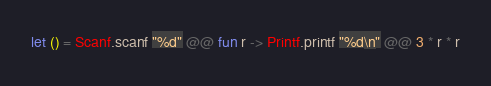<code> <loc_0><loc_0><loc_500><loc_500><_OCaml_>let () = Scanf.scanf "%d" @@ fun r -> Printf.printf "%d\n" @@ 3 * r * r</code> 